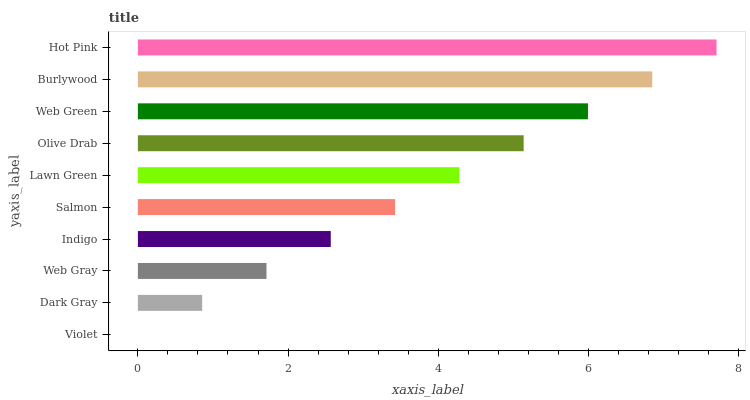Is Violet the minimum?
Answer yes or no. Yes. Is Hot Pink the maximum?
Answer yes or no. Yes. Is Dark Gray the minimum?
Answer yes or no. No. Is Dark Gray the maximum?
Answer yes or no. No. Is Dark Gray greater than Violet?
Answer yes or no. Yes. Is Violet less than Dark Gray?
Answer yes or no. Yes. Is Violet greater than Dark Gray?
Answer yes or no. No. Is Dark Gray less than Violet?
Answer yes or no. No. Is Lawn Green the high median?
Answer yes or no. Yes. Is Salmon the low median?
Answer yes or no. Yes. Is Salmon the high median?
Answer yes or no. No. Is Dark Gray the low median?
Answer yes or no. No. 